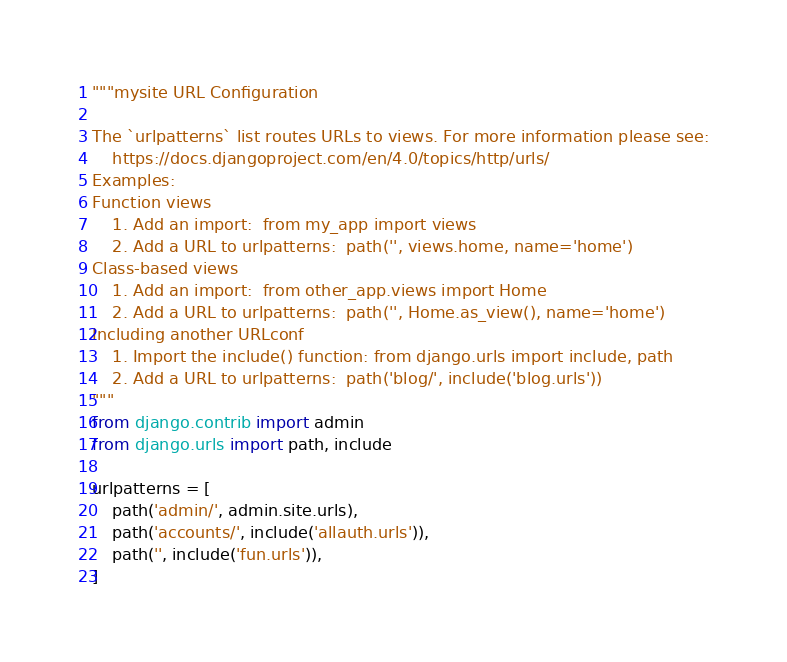<code> <loc_0><loc_0><loc_500><loc_500><_Python_>"""mysite URL Configuration

The `urlpatterns` list routes URLs to views. For more information please see:
    https://docs.djangoproject.com/en/4.0/topics/http/urls/
Examples:
Function views
    1. Add an import:  from my_app import views
    2. Add a URL to urlpatterns:  path('', views.home, name='home')
Class-based views
    1. Add an import:  from other_app.views import Home
    2. Add a URL to urlpatterns:  path('', Home.as_view(), name='home')
Including another URLconf
    1. Import the include() function: from django.urls import include, path
    2. Add a URL to urlpatterns:  path('blog/', include('blog.urls'))
"""
from django.contrib import admin
from django.urls import path, include

urlpatterns = [
    path('admin/', admin.site.urls),
    path('accounts/', include('allauth.urls')),
    path('', include('fun.urls')),
]
</code> 